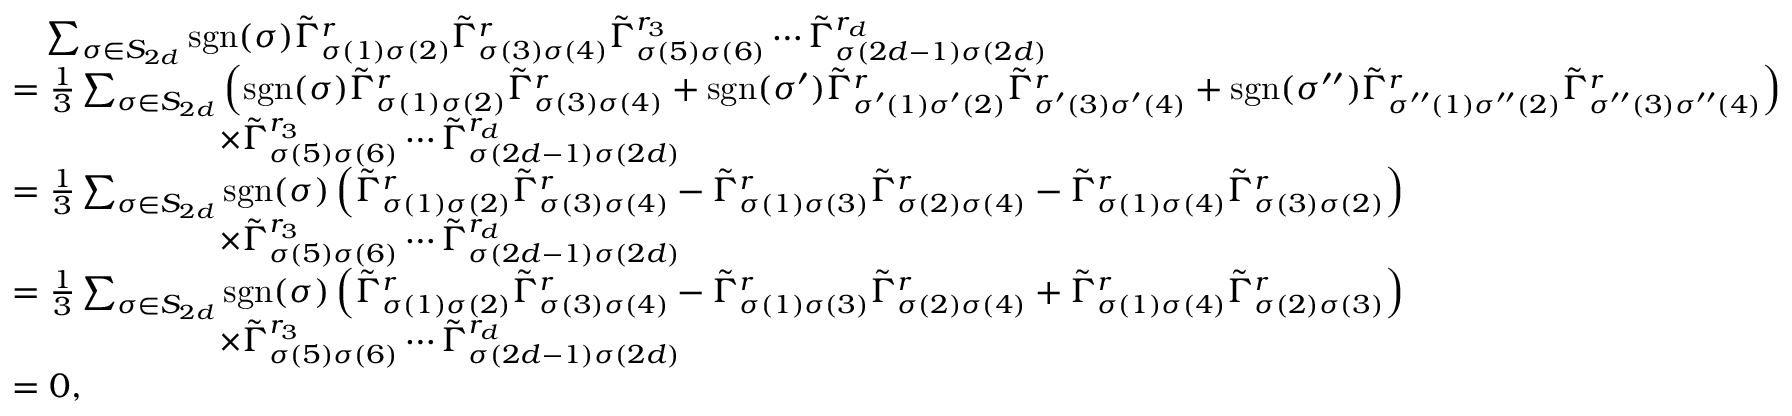Convert formula to latex. <formula><loc_0><loc_0><loc_500><loc_500>\begin{array} { r l } & { \quad \sum _ { \sigma \in S _ { 2 d } } s g n ( \sigma ) \tilde { \Gamma } _ { \sigma ( 1 ) \sigma ( 2 ) } ^ { r } \tilde { \Gamma } _ { \sigma ( 3 ) \sigma ( 4 ) } ^ { r } \tilde { \Gamma } _ { \sigma ( 5 ) \sigma ( 6 ) } ^ { r _ { 3 } } \cdots \tilde { \Gamma } _ { \sigma ( 2 d - 1 ) \sigma ( 2 d ) } ^ { r _ { d } } } \\ & { = \frac { 1 } { 3 } \sum _ { \sigma \in S _ { 2 d } } \left ( s g n ( \sigma ) \tilde { \Gamma } _ { \sigma ( 1 ) \sigma ( 2 ) } ^ { r } \tilde { \Gamma } _ { \sigma ( 3 ) \sigma ( 4 ) } ^ { r } + s g n ( \sigma ^ { \prime } ) \tilde { \Gamma } _ { \sigma ^ { \prime } ( 1 ) \sigma ^ { \prime } ( 2 ) } ^ { r } \tilde { \Gamma } _ { \sigma ^ { \prime } ( 3 ) \sigma ^ { \prime } ( 4 ) } ^ { r } + s g n ( \sigma ^ { \prime \prime } ) \tilde { \Gamma } _ { \sigma ^ { \prime \prime } ( 1 ) \sigma ^ { \prime \prime } ( 2 ) } ^ { r } \tilde { \Gamma } _ { \sigma ^ { \prime \prime } ( 3 ) \sigma ^ { \prime \prime } ( 4 ) } ^ { r } \right ) } \\ & { \quad \times \tilde { \Gamma } _ { \sigma ( 5 ) \sigma ( 6 ) } ^ { r _ { 3 } } \cdots \tilde { \Gamma } _ { \sigma ( 2 d - 1 ) \sigma ( 2 d ) } ^ { r _ { d } } } \\ & { = \frac { 1 } { 3 } \sum _ { \sigma \in S _ { 2 d } } s g n ( \sigma ) \left ( \tilde { \Gamma } _ { \sigma ( 1 ) \sigma ( 2 ) } ^ { r } \tilde { \Gamma } _ { \sigma ( 3 ) \sigma ( 4 ) } ^ { r } - \tilde { \Gamma } _ { \sigma ( 1 ) \sigma ( 3 ) } ^ { r } \tilde { \Gamma } _ { \sigma ( 2 ) \sigma ( 4 ) } ^ { r } - \tilde { \Gamma } _ { \sigma ( 1 ) \sigma ( 4 ) } ^ { r } \tilde { \Gamma } _ { \sigma ( 3 ) \sigma ( 2 ) } ^ { r } \right ) } \\ & { \quad \times \tilde { \Gamma } _ { \sigma ( 5 ) \sigma ( 6 ) } ^ { r _ { 3 } } \cdots \tilde { \Gamma } _ { \sigma ( 2 d - 1 ) \sigma ( 2 d ) } ^ { r _ { d } } } \\ & { = \frac { 1 } { 3 } \sum _ { \sigma \in S _ { 2 d } } s g n ( \sigma ) \left ( \tilde { \Gamma } _ { \sigma ( 1 ) \sigma ( 2 ) } ^ { r } \tilde { \Gamma } _ { \sigma ( 3 ) \sigma ( 4 ) } ^ { r } - \tilde { \Gamma } _ { \sigma ( 1 ) \sigma ( 3 ) } ^ { r } \tilde { \Gamma } _ { \sigma ( 2 ) \sigma ( 4 ) } ^ { r } + \tilde { \Gamma } _ { \sigma ( 1 ) \sigma ( 4 ) } ^ { r } \tilde { \Gamma } _ { \sigma ( 2 ) \sigma ( 3 ) } ^ { r } \right ) } \\ & { \quad \times \tilde { \Gamma } _ { \sigma ( 5 ) \sigma ( 6 ) } ^ { r _ { 3 } } \cdots \tilde { \Gamma } _ { \sigma ( 2 d - 1 ) \sigma ( 2 d ) } ^ { r _ { d } } } \\ & { = 0 , } \end{array}</formula> 